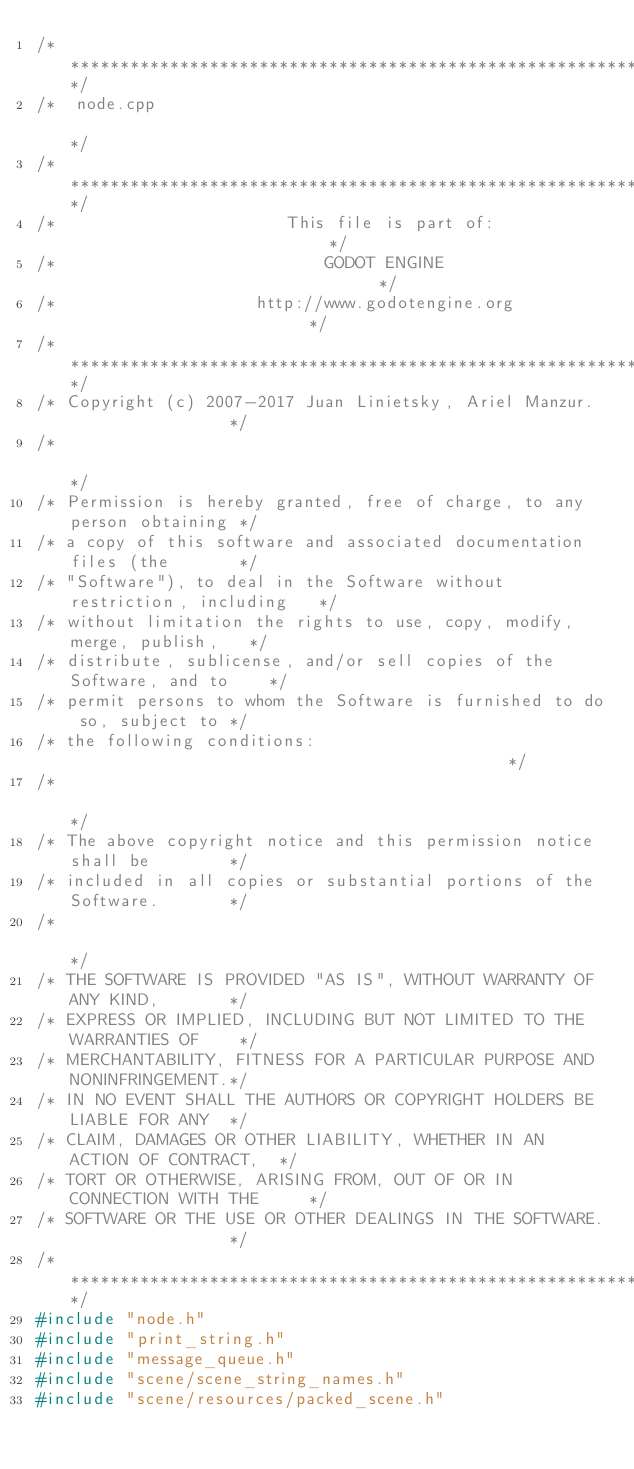<code> <loc_0><loc_0><loc_500><loc_500><_C++_>/*************************************************************************/
/*  node.cpp                                                             */
/*************************************************************************/
/*                       This file is part of:                           */
/*                           GODOT ENGINE                                */
/*                    http://www.godotengine.org                         */
/*************************************************************************/
/* Copyright (c) 2007-2017 Juan Linietsky, Ariel Manzur.                 */
/*                                                                       */
/* Permission is hereby granted, free of charge, to any person obtaining */
/* a copy of this software and associated documentation files (the       */
/* "Software"), to deal in the Software without restriction, including   */
/* without limitation the rights to use, copy, modify, merge, publish,   */
/* distribute, sublicense, and/or sell copies of the Software, and to    */
/* permit persons to whom the Software is furnished to do so, subject to */
/* the following conditions:                                             */
/*                                                                       */
/* The above copyright notice and this permission notice shall be        */
/* included in all copies or substantial portions of the Software.       */
/*                                                                       */
/* THE SOFTWARE IS PROVIDED "AS IS", WITHOUT WARRANTY OF ANY KIND,       */
/* EXPRESS OR IMPLIED, INCLUDING BUT NOT LIMITED TO THE WARRANTIES OF    */
/* MERCHANTABILITY, FITNESS FOR A PARTICULAR PURPOSE AND NONINFRINGEMENT.*/
/* IN NO EVENT SHALL THE AUTHORS OR COPYRIGHT HOLDERS BE LIABLE FOR ANY  */
/* CLAIM, DAMAGES OR OTHER LIABILITY, WHETHER IN AN ACTION OF CONTRACT,  */
/* TORT OR OTHERWISE, ARISING FROM, OUT OF OR IN CONNECTION WITH THE     */
/* SOFTWARE OR THE USE OR OTHER DEALINGS IN THE SOFTWARE.                */
/*************************************************************************/
#include "node.h"
#include "print_string.h"
#include "message_queue.h"
#include "scene/scene_string_names.h"
#include "scene/resources/packed_scene.h"</code> 